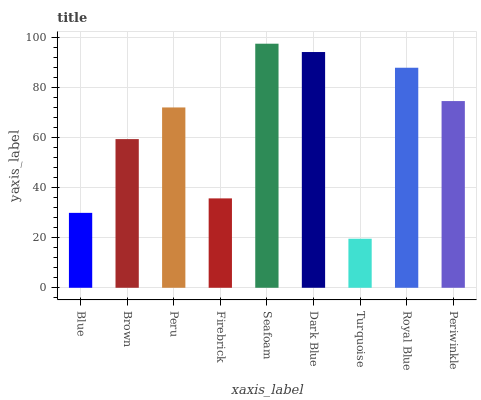Is Turquoise the minimum?
Answer yes or no. Yes. Is Seafoam the maximum?
Answer yes or no. Yes. Is Brown the minimum?
Answer yes or no. No. Is Brown the maximum?
Answer yes or no. No. Is Brown greater than Blue?
Answer yes or no. Yes. Is Blue less than Brown?
Answer yes or no. Yes. Is Blue greater than Brown?
Answer yes or no. No. Is Brown less than Blue?
Answer yes or no. No. Is Peru the high median?
Answer yes or no. Yes. Is Peru the low median?
Answer yes or no. Yes. Is Blue the high median?
Answer yes or no. No. Is Periwinkle the low median?
Answer yes or no. No. 